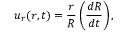<formula> <loc_0><loc_0><loc_500><loc_500>u _ { r } ( r , t ) = \frac { r } { R } \left ( \frac { d R } { d t } \right ) ,</formula> 